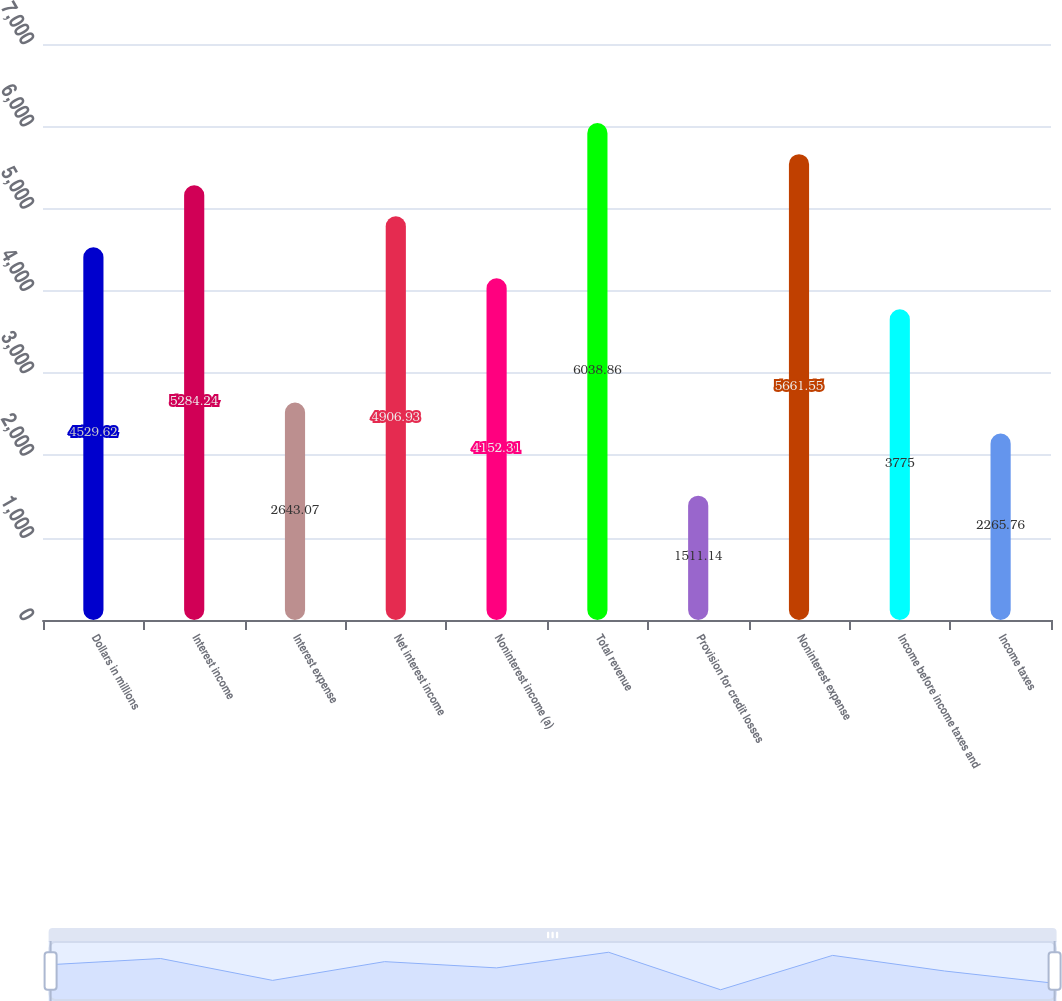<chart> <loc_0><loc_0><loc_500><loc_500><bar_chart><fcel>Dollars in millions<fcel>Interest income<fcel>Interest expense<fcel>Net interest income<fcel>Noninterest income (a)<fcel>Total revenue<fcel>Provision for credit losses<fcel>Noninterest expense<fcel>Income before income taxes and<fcel>Income taxes<nl><fcel>4529.62<fcel>5284.24<fcel>2643.07<fcel>4906.93<fcel>4152.31<fcel>6038.86<fcel>1511.14<fcel>5661.55<fcel>3775<fcel>2265.76<nl></chart> 